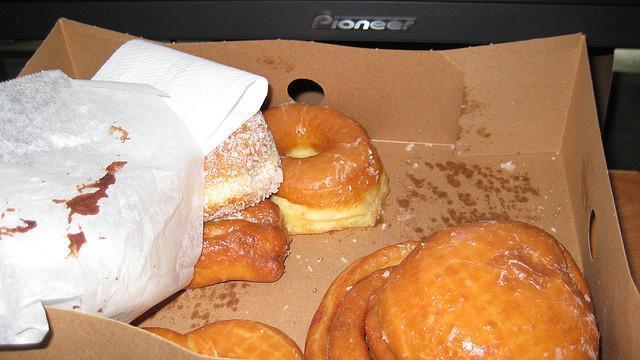How many donuts are in the photo?
Give a very brief answer. 5. How many people are wearing glasses?
Give a very brief answer. 0. 